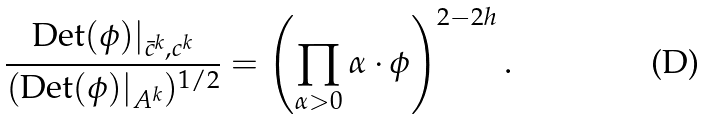Convert formula to latex. <formula><loc_0><loc_0><loc_500><loc_500>\frac { \text {Det} ( \phi ) | _ { \bar { c } ^ { k } , c ^ { k } } } { ( \text {Det} ( \phi ) | _ { A ^ { k } } ) ^ { 1 / 2 } } = \left ( \prod _ { \alpha > 0 } \alpha \cdot \phi \right ) ^ { 2 - 2 h } .</formula> 